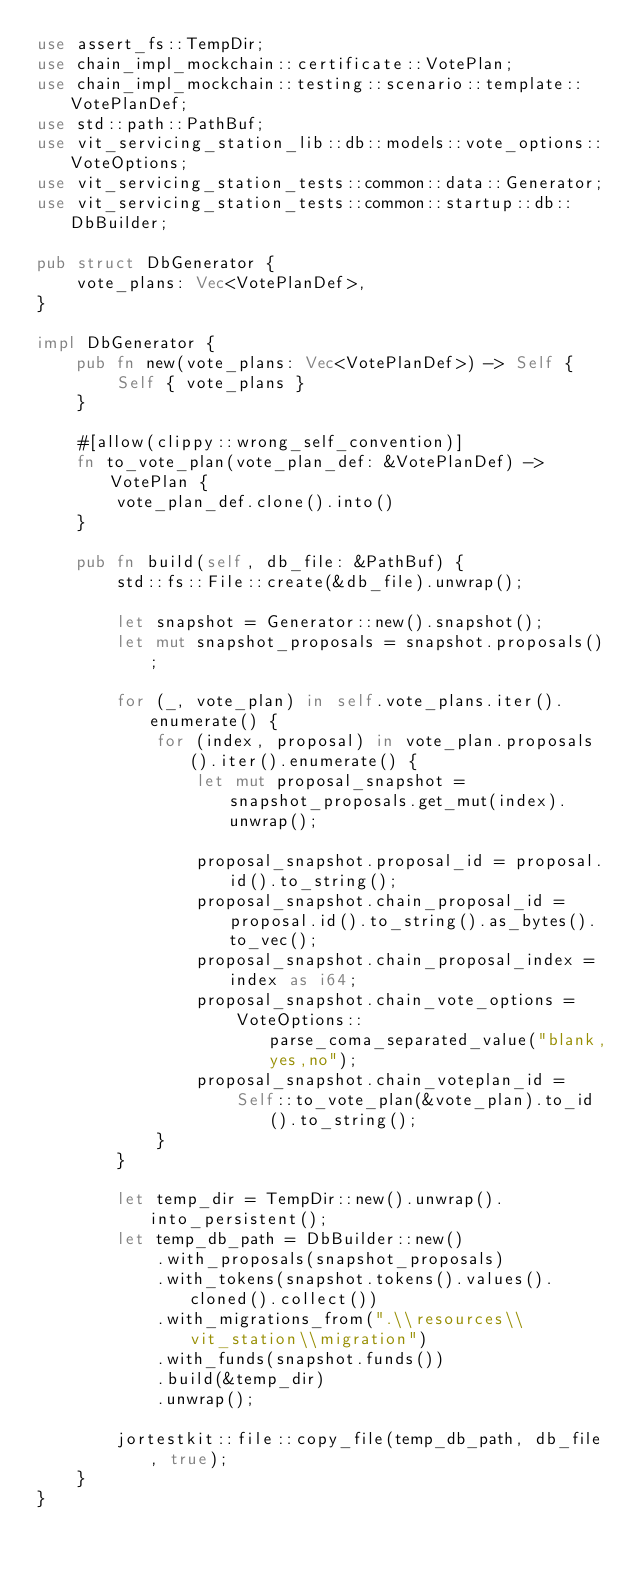Convert code to text. <code><loc_0><loc_0><loc_500><loc_500><_Rust_>use assert_fs::TempDir;
use chain_impl_mockchain::certificate::VotePlan;
use chain_impl_mockchain::testing::scenario::template::VotePlanDef;
use std::path::PathBuf;
use vit_servicing_station_lib::db::models::vote_options::VoteOptions;
use vit_servicing_station_tests::common::data::Generator;
use vit_servicing_station_tests::common::startup::db::DbBuilder;

pub struct DbGenerator {
    vote_plans: Vec<VotePlanDef>,
}

impl DbGenerator {
    pub fn new(vote_plans: Vec<VotePlanDef>) -> Self {
        Self { vote_plans }
    }

    #[allow(clippy::wrong_self_convention)]
    fn to_vote_plan(vote_plan_def: &VotePlanDef) -> VotePlan {
        vote_plan_def.clone().into()
    }

    pub fn build(self, db_file: &PathBuf) {
        std::fs::File::create(&db_file).unwrap();

        let snapshot = Generator::new().snapshot();
        let mut snapshot_proposals = snapshot.proposals();

        for (_, vote_plan) in self.vote_plans.iter().enumerate() {
            for (index, proposal) in vote_plan.proposals().iter().enumerate() {
                let mut proposal_snapshot = snapshot_proposals.get_mut(index).unwrap();

                proposal_snapshot.proposal_id = proposal.id().to_string();
                proposal_snapshot.chain_proposal_id = proposal.id().to_string().as_bytes().to_vec();
                proposal_snapshot.chain_proposal_index = index as i64;
                proposal_snapshot.chain_vote_options =
                    VoteOptions::parse_coma_separated_value("blank,yes,no");
                proposal_snapshot.chain_voteplan_id =
                    Self::to_vote_plan(&vote_plan).to_id().to_string();
            }
        }

        let temp_dir = TempDir::new().unwrap().into_persistent();
        let temp_db_path = DbBuilder::new()
            .with_proposals(snapshot_proposals)
            .with_tokens(snapshot.tokens().values().cloned().collect())
            .with_migrations_from(".\\resources\\vit_station\\migration")
            .with_funds(snapshot.funds())
            .build(&temp_dir)
            .unwrap();

        jortestkit::file::copy_file(temp_db_path, db_file, true);
    }
}
</code> 